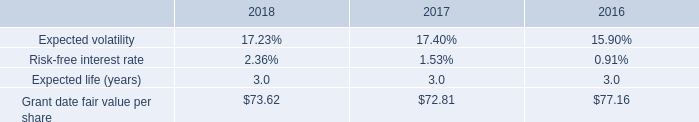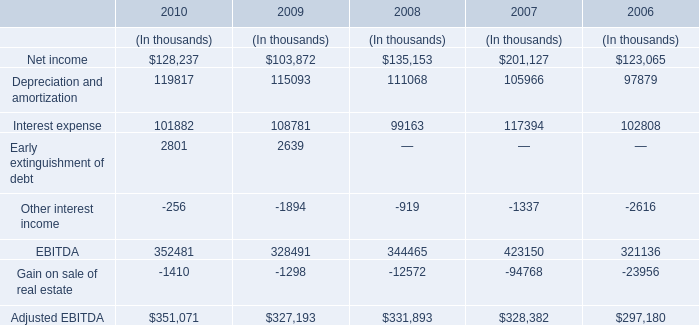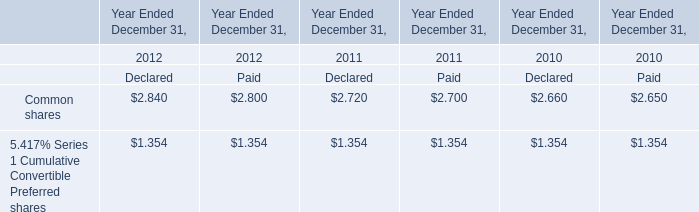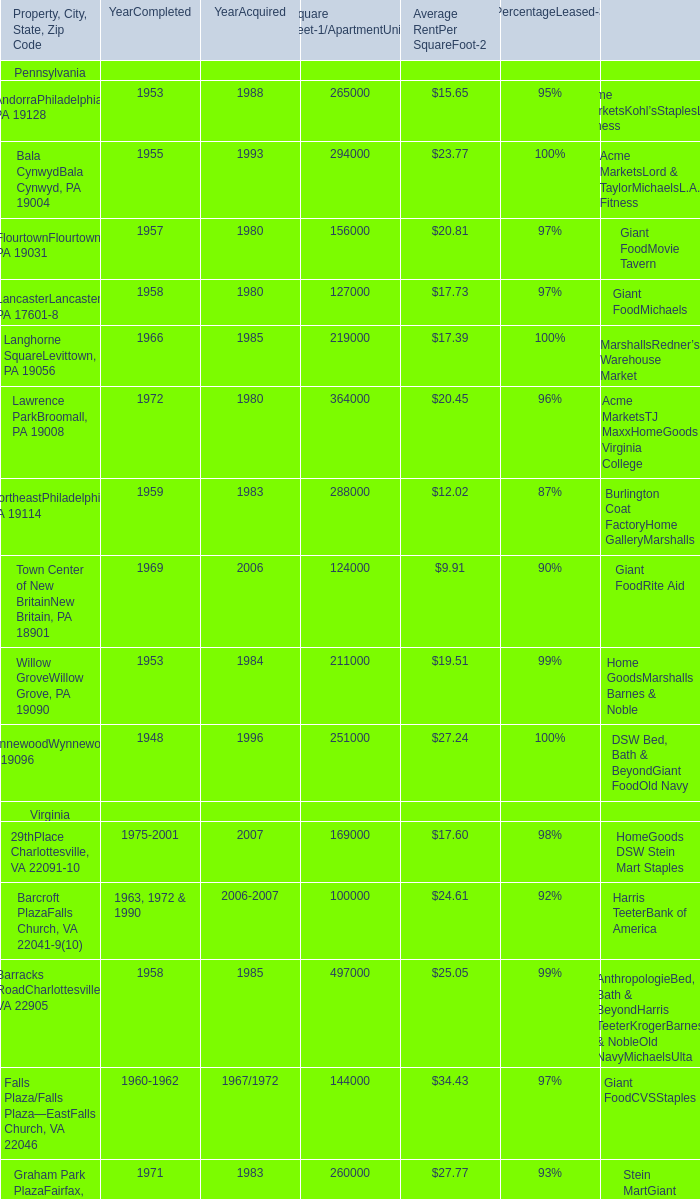by how much did the grant date fair value per share increase from 2017 to 2018? 
Computations: ((73.62 - 72.81) / 72.81)
Answer: 0.01112. 